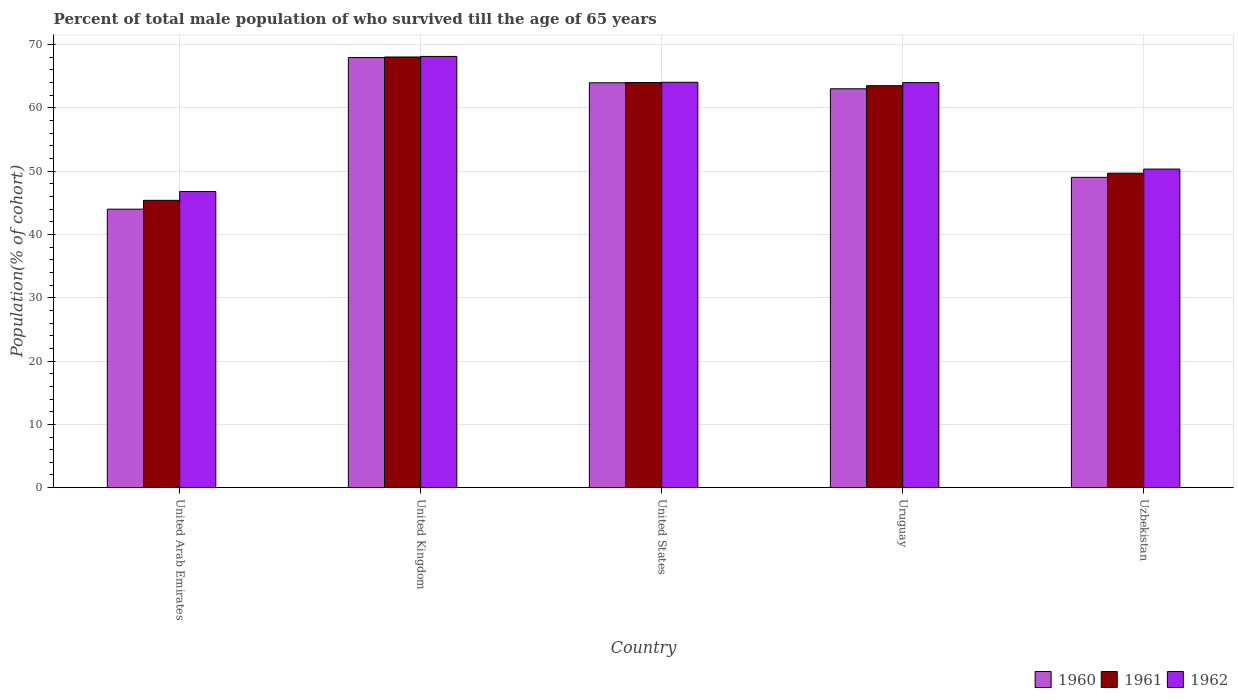How many different coloured bars are there?
Provide a succinct answer. 3. Are the number of bars on each tick of the X-axis equal?
Give a very brief answer. Yes. How many bars are there on the 1st tick from the right?
Give a very brief answer. 3. What is the percentage of total male population who survived till the age of 65 years in 1962 in Uzbekistan?
Your answer should be compact. 50.33. Across all countries, what is the maximum percentage of total male population who survived till the age of 65 years in 1961?
Give a very brief answer. 68.04. Across all countries, what is the minimum percentage of total male population who survived till the age of 65 years in 1960?
Provide a succinct answer. 44. In which country was the percentage of total male population who survived till the age of 65 years in 1962 minimum?
Ensure brevity in your answer.  United Arab Emirates. What is the total percentage of total male population who survived till the age of 65 years in 1962 in the graph?
Provide a succinct answer. 293.27. What is the difference between the percentage of total male population who survived till the age of 65 years in 1962 in United Kingdom and that in Uzbekistan?
Your response must be concise. 17.8. What is the difference between the percentage of total male population who survived till the age of 65 years in 1962 in United States and the percentage of total male population who survived till the age of 65 years in 1960 in United Kingdom?
Your answer should be very brief. -3.91. What is the average percentage of total male population who survived till the age of 65 years in 1962 per country?
Offer a very short reply. 58.65. What is the difference between the percentage of total male population who survived till the age of 65 years of/in 1962 and percentage of total male population who survived till the age of 65 years of/in 1960 in United Kingdom?
Make the answer very short. 0.18. What is the ratio of the percentage of total male population who survived till the age of 65 years in 1962 in United Arab Emirates to that in Uzbekistan?
Provide a short and direct response. 0.93. What is the difference between the highest and the second highest percentage of total male population who survived till the age of 65 years in 1962?
Provide a succinct answer. -4.08. What is the difference between the highest and the lowest percentage of total male population who survived till the age of 65 years in 1960?
Your answer should be very brief. 23.95. In how many countries, is the percentage of total male population who survived till the age of 65 years in 1961 greater than the average percentage of total male population who survived till the age of 65 years in 1961 taken over all countries?
Provide a succinct answer. 3. Are all the bars in the graph horizontal?
Keep it short and to the point. No. How many countries are there in the graph?
Keep it short and to the point. 5. What is the difference between two consecutive major ticks on the Y-axis?
Your answer should be compact. 10. Are the values on the major ticks of Y-axis written in scientific E-notation?
Give a very brief answer. No. Does the graph contain grids?
Your response must be concise. Yes. Where does the legend appear in the graph?
Ensure brevity in your answer.  Bottom right. How are the legend labels stacked?
Provide a succinct answer. Horizontal. What is the title of the graph?
Make the answer very short. Percent of total male population of who survived till the age of 65 years. Does "1987" appear as one of the legend labels in the graph?
Your answer should be compact. No. What is the label or title of the X-axis?
Give a very brief answer. Country. What is the label or title of the Y-axis?
Your answer should be very brief. Population(% of cohort). What is the Population(% of cohort) in 1960 in United Arab Emirates?
Your answer should be very brief. 44. What is the Population(% of cohort) in 1961 in United Arab Emirates?
Keep it short and to the point. 45.39. What is the Population(% of cohort) in 1962 in United Arab Emirates?
Provide a short and direct response. 46.78. What is the Population(% of cohort) in 1960 in United Kingdom?
Ensure brevity in your answer.  67.95. What is the Population(% of cohort) in 1961 in United Kingdom?
Your answer should be compact. 68.04. What is the Population(% of cohort) in 1962 in United Kingdom?
Provide a succinct answer. 68.13. What is the Population(% of cohort) of 1960 in United States?
Keep it short and to the point. 63.96. What is the Population(% of cohort) in 1961 in United States?
Ensure brevity in your answer.  64. What is the Population(% of cohort) of 1962 in United States?
Offer a very short reply. 64.04. What is the Population(% of cohort) of 1960 in Uruguay?
Your response must be concise. 63.02. What is the Population(% of cohort) of 1961 in Uruguay?
Provide a short and direct response. 63.5. What is the Population(% of cohort) of 1962 in Uruguay?
Keep it short and to the point. 63.99. What is the Population(% of cohort) of 1960 in Uzbekistan?
Your answer should be very brief. 49.03. What is the Population(% of cohort) in 1961 in Uzbekistan?
Ensure brevity in your answer.  49.68. What is the Population(% of cohort) in 1962 in Uzbekistan?
Your answer should be compact. 50.33. Across all countries, what is the maximum Population(% of cohort) of 1960?
Give a very brief answer. 67.95. Across all countries, what is the maximum Population(% of cohort) of 1961?
Keep it short and to the point. 68.04. Across all countries, what is the maximum Population(% of cohort) of 1962?
Offer a very short reply. 68.13. Across all countries, what is the minimum Population(% of cohort) in 1960?
Offer a terse response. 44. Across all countries, what is the minimum Population(% of cohort) of 1961?
Provide a succinct answer. 45.39. Across all countries, what is the minimum Population(% of cohort) in 1962?
Offer a terse response. 46.78. What is the total Population(% of cohort) in 1960 in the graph?
Offer a terse response. 287.95. What is the total Population(% of cohort) in 1961 in the graph?
Your answer should be very brief. 290.61. What is the total Population(% of cohort) in 1962 in the graph?
Give a very brief answer. 293.27. What is the difference between the Population(% of cohort) of 1960 in United Arab Emirates and that in United Kingdom?
Offer a very short reply. -23.95. What is the difference between the Population(% of cohort) in 1961 in United Arab Emirates and that in United Kingdom?
Your answer should be very brief. -22.65. What is the difference between the Population(% of cohort) of 1962 in United Arab Emirates and that in United Kingdom?
Provide a succinct answer. -21.35. What is the difference between the Population(% of cohort) in 1960 in United Arab Emirates and that in United States?
Your answer should be very brief. -19.96. What is the difference between the Population(% of cohort) of 1961 in United Arab Emirates and that in United States?
Offer a very short reply. -18.61. What is the difference between the Population(% of cohort) in 1962 in United Arab Emirates and that in United States?
Give a very brief answer. -17.26. What is the difference between the Population(% of cohort) in 1960 in United Arab Emirates and that in Uruguay?
Your answer should be compact. -19.02. What is the difference between the Population(% of cohort) in 1961 in United Arab Emirates and that in Uruguay?
Provide a short and direct response. -18.11. What is the difference between the Population(% of cohort) of 1962 in United Arab Emirates and that in Uruguay?
Your answer should be very brief. -17.21. What is the difference between the Population(% of cohort) of 1960 in United Arab Emirates and that in Uzbekistan?
Offer a very short reply. -5.03. What is the difference between the Population(% of cohort) in 1961 in United Arab Emirates and that in Uzbekistan?
Provide a succinct answer. -4.29. What is the difference between the Population(% of cohort) in 1962 in United Arab Emirates and that in Uzbekistan?
Give a very brief answer. -3.55. What is the difference between the Population(% of cohort) in 1960 in United Kingdom and that in United States?
Ensure brevity in your answer.  3.99. What is the difference between the Population(% of cohort) of 1961 in United Kingdom and that in United States?
Ensure brevity in your answer.  4.04. What is the difference between the Population(% of cohort) in 1962 in United Kingdom and that in United States?
Give a very brief answer. 4.08. What is the difference between the Population(% of cohort) in 1960 in United Kingdom and that in Uruguay?
Provide a short and direct response. 4.94. What is the difference between the Population(% of cohort) in 1961 in United Kingdom and that in Uruguay?
Offer a terse response. 4.54. What is the difference between the Population(% of cohort) of 1962 in United Kingdom and that in Uruguay?
Your answer should be very brief. 4.14. What is the difference between the Population(% of cohort) of 1960 in United Kingdom and that in Uzbekistan?
Provide a short and direct response. 18.92. What is the difference between the Population(% of cohort) of 1961 in United Kingdom and that in Uzbekistan?
Offer a terse response. 18.36. What is the difference between the Population(% of cohort) in 1962 in United Kingdom and that in Uzbekistan?
Provide a succinct answer. 17.8. What is the difference between the Population(% of cohort) of 1960 in United States and that in Uruguay?
Make the answer very short. 0.94. What is the difference between the Population(% of cohort) of 1961 in United States and that in Uruguay?
Provide a succinct answer. 0.5. What is the difference between the Population(% of cohort) of 1962 in United States and that in Uruguay?
Ensure brevity in your answer.  0.06. What is the difference between the Population(% of cohort) of 1960 in United States and that in Uzbekistan?
Ensure brevity in your answer.  14.93. What is the difference between the Population(% of cohort) of 1961 in United States and that in Uzbekistan?
Ensure brevity in your answer.  14.32. What is the difference between the Population(% of cohort) in 1962 in United States and that in Uzbekistan?
Offer a very short reply. 13.71. What is the difference between the Population(% of cohort) in 1960 in Uruguay and that in Uzbekistan?
Give a very brief answer. 13.99. What is the difference between the Population(% of cohort) of 1961 in Uruguay and that in Uzbekistan?
Provide a short and direct response. 13.82. What is the difference between the Population(% of cohort) of 1962 in Uruguay and that in Uzbekistan?
Offer a terse response. 13.66. What is the difference between the Population(% of cohort) in 1960 in United Arab Emirates and the Population(% of cohort) in 1961 in United Kingdom?
Keep it short and to the point. -24.04. What is the difference between the Population(% of cohort) of 1960 in United Arab Emirates and the Population(% of cohort) of 1962 in United Kingdom?
Offer a terse response. -24.13. What is the difference between the Population(% of cohort) in 1961 in United Arab Emirates and the Population(% of cohort) in 1962 in United Kingdom?
Your response must be concise. -22.74. What is the difference between the Population(% of cohort) of 1960 in United Arab Emirates and the Population(% of cohort) of 1961 in United States?
Your answer should be compact. -20. What is the difference between the Population(% of cohort) of 1960 in United Arab Emirates and the Population(% of cohort) of 1962 in United States?
Provide a succinct answer. -20.05. What is the difference between the Population(% of cohort) of 1961 in United Arab Emirates and the Population(% of cohort) of 1962 in United States?
Offer a very short reply. -18.66. What is the difference between the Population(% of cohort) in 1960 in United Arab Emirates and the Population(% of cohort) in 1961 in Uruguay?
Your answer should be very brief. -19.5. What is the difference between the Population(% of cohort) of 1960 in United Arab Emirates and the Population(% of cohort) of 1962 in Uruguay?
Your answer should be compact. -19.99. What is the difference between the Population(% of cohort) of 1961 in United Arab Emirates and the Population(% of cohort) of 1962 in Uruguay?
Your answer should be very brief. -18.6. What is the difference between the Population(% of cohort) of 1960 in United Arab Emirates and the Population(% of cohort) of 1961 in Uzbekistan?
Your answer should be compact. -5.68. What is the difference between the Population(% of cohort) in 1960 in United Arab Emirates and the Population(% of cohort) in 1962 in Uzbekistan?
Keep it short and to the point. -6.33. What is the difference between the Population(% of cohort) in 1961 in United Arab Emirates and the Population(% of cohort) in 1962 in Uzbekistan?
Provide a short and direct response. -4.94. What is the difference between the Population(% of cohort) in 1960 in United Kingdom and the Population(% of cohort) in 1961 in United States?
Provide a succinct answer. 3.95. What is the difference between the Population(% of cohort) of 1960 in United Kingdom and the Population(% of cohort) of 1962 in United States?
Offer a terse response. 3.91. What is the difference between the Population(% of cohort) of 1961 in United Kingdom and the Population(% of cohort) of 1962 in United States?
Your response must be concise. 3.99. What is the difference between the Population(% of cohort) of 1960 in United Kingdom and the Population(% of cohort) of 1961 in Uruguay?
Your answer should be compact. 4.45. What is the difference between the Population(% of cohort) in 1960 in United Kingdom and the Population(% of cohort) in 1962 in Uruguay?
Your answer should be compact. 3.96. What is the difference between the Population(% of cohort) in 1961 in United Kingdom and the Population(% of cohort) in 1962 in Uruguay?
Ensure brevity in your answer.  4.05. What is the difference between the Population(% of cohort) of 1960 in United Kingdom and the Population(% of cohort) of 1961 in Uzbekistan?
Your response must be concise. 18.27. What is the difference between the Population(% of cohort) of 1960 in United Kingdom and the Population(% of cohort) of 1962 in Uzbekistan?
Offer a terse response. 17.62. What is the difference between the Population(% of cohort) of 1961 in United Kingdom and the Population(% of cohort) of 1962 in Uzbekistan?
Your answer should be very brief. 17.71. What is the difference between the Population(% of cohort) of 1960 in United States and the Population(% of cohort) of 1961 in Uruguay?
Provide a short and direct response. 0.46. What is the difference between the Population(% of cohort) in 1960 in United States and the Population(% of cohort) in 1962 in Uruguay?
Your answer should be compact. -0.03. What is the difference between the Population(% of cohort) of 1961 in United States and the Population(% of cohort) of 1962 in Uruguay?
Ensure brevity in your answer.  0.01. What is the difference between the Population(% of cohort) of 1960 in United States and the Population(% of cohort) of 1961 in Uzbekistan?
Give a very brief answer. 14.28. What is the difference between the Population(% of cohort) in 1960 in United States and the Population(% of cohort) in 1962 in Uzbekistan?
Provide a short and direct response. 13.63. What is the difference between the Population(% of cohort) of 1961 in United States and the Population(% of cohort) of 1962 in Uzbekistan?
Your response must be concise. 13.67. What is the difference between the Population(% of cohort) in 1960 in Uruguay and the Population(% of cohort) in 1961 in Uzbekistan?
Make the answer very short. 13.34. What is the difference between the Population(% of cohort) in 1960 in Uruguay and the Population(% of cohort) in 1962 in Uzbekistan?
Make the answer very short. 12.69. What is the difference between the Population(% of cohort) in 1961 in Uruguay and the Population(% of cohort) in 1962 in Uzbekistan?
Offer a very short reply. 13.17. What is the average Population(% of cohort) in 1960 per country?
Keep it short and to the point. 57.59. What is the average Population(% of cohort) in 1961 per country?
Give a very brief answer. 58.12. What is the average Population(% of cohort) in 1962 per country?
Offer a very short reply. 58.65. What is the difference between the Population(% of cohort) in 1960 and Population(% of cohort) in 1961 in United Arab Emirates?
Ensure brevity in your answer.  -1.39. What is the difference between the Population(% of cohort) of 1960 and Population(% of cohort) of 1962 in United Arab Emirates?
Provide a short and direct response. -2.78. What is the difference between the Population(% of cohort) in 1961 and Population(% of cohort) in 1962 in United Arab Emirates?
Offer a very short reply. -1.39. What is the difference between the Population(% of cohort) of 1960 and Population(% of cohort) of 1961 in United Kingdom?
Provide a succinct answer. -0.09. What is the difference between the Population(% of cohort) in 1960 and Population(% of cohort) in 1962 in United Kingdom?
Offer a very short reply. -0.18. What is the difference between the Population(% of cohort) in 1961 and Population(% of cohort) in 1962 in United Kingdom?
Your response must be concise. -0.09. What is the difference between the Population(% of cohort) of 1960 and Population(% of cohort) of 1961 in United States?
Offer a terse response. -0.04. What is the difference between the Population(% of cohort) in 1960 and Population(% of cohort) in 1962 in United States?
Your answer should be compact. -0.08. What is the difference between the Population(% of cohort) in 1961 and Population(% of cohort) in 1962 in United States?
Offer a very short reply. -0.04. What is the difference between the Population(% of cohort) in 1960 and Population(% of cohort) in 1961 in Uruguay?
Ensure brevity in your answer.  -0.49. What is the difference between the Population(% of cohort) in 1960 and Population(% of cohort) in 1962 in Uruguay?
Offer a very short reply. -0.97. What is the difference between the Population(% of cohort) in 1961 and Population(% of cohort) in 1962 in Uruguay?
Offer a very short reply. -0.49. What is the difference between the Population(% of cohort) in 1960 and Population(% of cohort) in 1961 in Uzbekistan?
Your answer should be compact. -0.65. What is the difference between the Population(% of cohort) of 1960 and Population(% of cohort) of 1962 in Uzbekistan?
Offer a very short reply. -1.3. What is the difference between the Population(% of cohort) in 1961 and Population(% of cohort) in 1962 in Uzbekistan?
Make the answer very short. -0.65. What is the ratio of the Population(% of cohort) in 1960 in United Arab Emirates to that in United Kingdom?
Give a very brief answer. 0.65. What is the ratio of the Population(% of cohort) of 1961 in United Arab Emirates to that in United Kingdom?
Your answer should be very brief. 0.67. What is the ratio of the Population(% of cohort) of 1962 in United Arab Emirates to that in United Kingdom?
Your answer should be very brief. 0.69. What is the ratio of the Population(% of cohort) of 1960 in United Arab Emirates to that in United States?
Your answer should be very brief. 0.69. What is the ratio of the Population(% of cohort) in 1961 in United Arab Emirates to that in United States?
Your response must be concise. 0.71. What is the ratio of the Population(% of cohort) of 1962 in United Arab Emirates to that in United States?
Give a very brief answer. 0.73. What is the ratio of the Population(% of cohort) in 1960 in United Arab Emirates to that in Uruguay?
Keep it short and to the point. 0.7. What is the ratio of the Population(% of cohort) in 1961 in United Arab Emirates to that in Uruguay?
Your answer should be very brief. 0.71. What is the ratio of the Population(% of cohort) of 1962 in United Arab Emirates to that in Uruguay?
Provide a short and direct response. 0.73. What is the ratio of the Population(% of cohort) in 1960 in United Arab Emirates to that in Uzbekistan?
Provide a short and direct response. 0.9. What is the ratio of the Population(% of cohort) of 1961 in United Arab Emirates to that in Uzbekistan?
Provide a succinct answer. 0.91. What is the ratio of the Population(% of cohort) in 1962 in United Arab Emirates to that in Uzbekistan?
Provide a short and direct response. 0.93. What is the ratio of the Population(% of cohort) in 1960 in United Kingdom to that in United States?
Make the answer very short. 1.06. What is the ratio of the Population(% of cohort) of 1961 in United Kingdom to that in United States?
Give a very brief answer. 1.06. What is the ratio of the Population(% of cohort) in 1962 in United Kingdom to that in United States?
Your answer should be compact. 1.06. What is the ratio of the Population(% of cohort) in 1960 in United Kingdom to that in Uruguay?
Your answer should be very brief. 1.08. What is the ratio of the Population(% of cohort) of 1961 in United Kingdom to that in Uruguay?
Ensure brevity in your answer.  1.07. What is the ratio of the Population(% of cohort) in 1962 in United Kingdom to that in Uruguay?
Keep it short and to the point. 1.06. What is the ratio of the Population(% of cohort) in 1960 in United Kingdom to that in Uzbekistan?
Give a very brief answer. 1.39. What is the ratio of the Population(% of cohort) of 1961 in United Kingdom to that in Uzbekistan?
Make the answer very short. 1.37. What is the ratio of the Population(% of cohort) in 1962 in United Kingdom to that in Uzbekistan?
Provide a succinct answer. 1.35. What is the ratio of the Population(% of cohort) in 1961 in United States to that in Uruguay?
Your answer should be compact. 1.01. What is the ratio of the Population(% of cohort) in 1962 in United States to that in Uruguay?
Ensure brevity in your answer.  1. What is the ratio of the Population(% of cohort) of 1960 in United States to that in Uzbekistan?
Your response must be concise. 1.3. What is the ratio of the Population(% of cohort) of 1961 in United States to that in Uzbekistan?
Your answer should be compact. 1.29. What is the ratio of the Population(% of cohort) of 1962 in United States to that in Uzbekistan?
Keep it short and to the point. 1.27. What is the ratio of the Population(% of cohort) in 1960 in Uruguay to that in Uzbekistan?
Make the answer very short. 1.29. What is the ratio of the Population(% of cohort) in 1961 in Uruguay to that in Uzbekistan?
Keep it short and to the point. 1.28. What is the ratio of the Population(% of cohort) in 1962 in Uruguay to that in Uzbekistan?
Keep it short and to the point. 1.27. What is the difference between the highest and the second highest Population(% of cohort) of 1960?
Keep it short and to the point. 3.99. What is the difference between the highest and the second highest Population(% of cohort) of 1961?
Your response must be concise. 4.04. What is the difference between the highest and the second highest Population(% of cohort) of 1962?
Offer a terse response. 4.08. What is the difference between the highest and the lowest Population(% of cohort) of 1960?
Your response must be concise. 23.95. What is the difference between the highest and the lowest Population(% of cohort) in 1961?
Give a very brief answer. 22.65. What is the difference between the highest and the lowest Population(% of cohort) of 1962?
Ensure brevity in your answer.  21.35. 